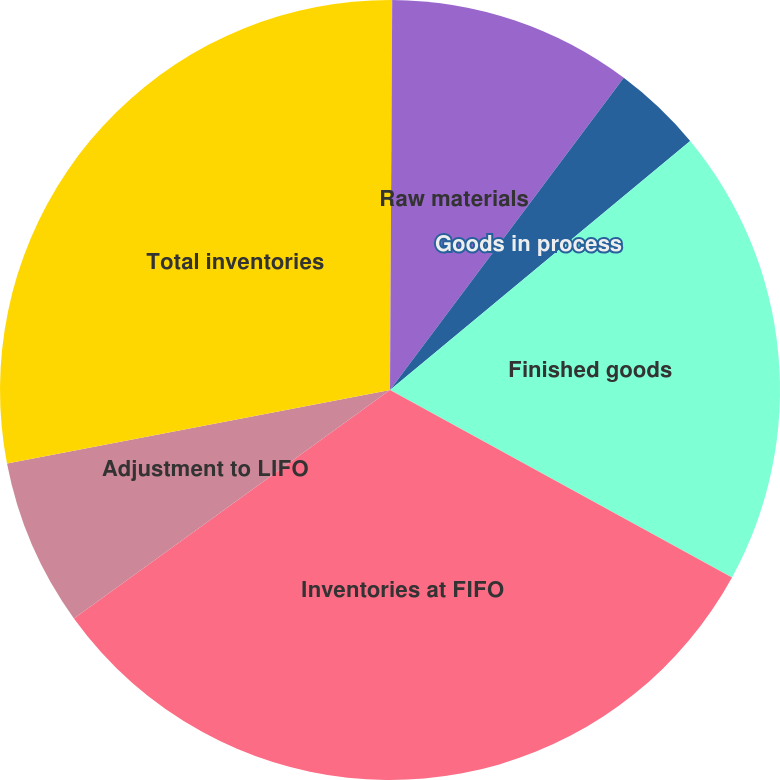Convert chart to OTSL. <chart><loc_0><loc_0><loc_500><loc_500><pie_chart><fcel>December 31<fcel>Raw materials<fcel>Goods in process<fcel>Finished goods<fcel>Inventories at FIFO<fcel>Adjustment to LIFO<fcel>Total inventories<nl><fcel>0.09%<fcel>10.14%<fcel>3.75%<fcel>19.0%<fcel>32.06%<fcel>6.94%<fcel>28.02%<nl></chart> 